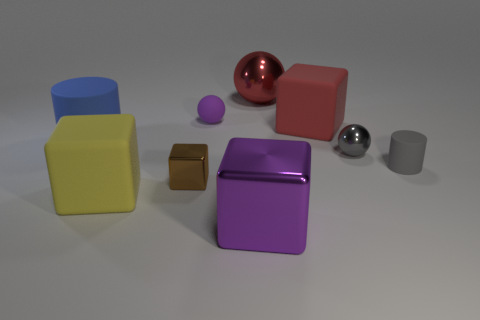Does the tiny cube have the same color as the big matte block that is in front of the small metallic sphere?
Ensure brevity in your answer.  No. What color is the tiny object that is in front of the big red matte cube and behind the gray matte cylinder?
Provide a short and direct response. Gray. What number of big rubber blocks are behind the matte cylinder that is in front of the tiny metallic sphere?
Your response must be concise. 1. Is there a red thing of the same shape as the big yellow object?
Make the answer very short. Yes. There is a big shiny thing that is in front of the gray shiny ball; is its shape the same as the tiny metallic thing that is on the right side of the tiny brown object?
Ensure brevity in your answer.  No. How many objects are big blue things or shiny objects?
Provide a short and direct response. 5. The blue object that is the same shape as the gray rubber thing is what size?
Offer a terse response. Large. Are there more red things behind the yellow matte thing than yellow shiny cubes?
Your response must be concise. Yes. Are the tiny cube and the blue cylinder made of the same material?
Provide a short and direct response. No. How many things are rubber objects that are behind the small cylinder or cylinders that are right of the red matte object?
Offer a very short reply. 4. 